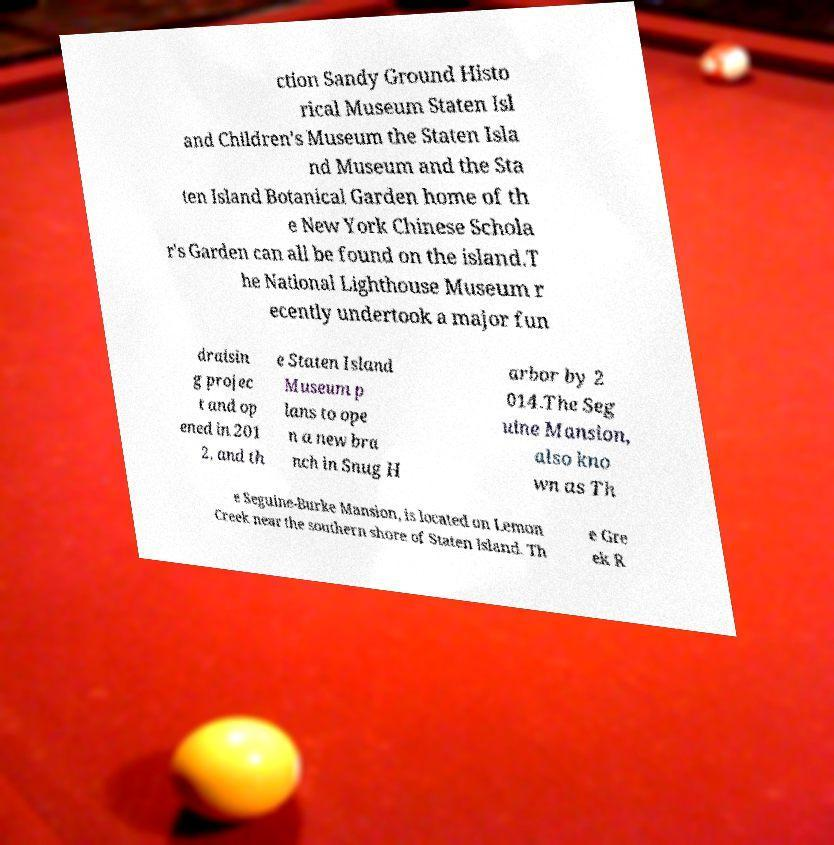What messages or text are displayed in this image? I need them in a readable, typed format. ction Sandy Ground Histo rical Museum Staten Isl and Children's Museum the Staten Isla nd Museum and the Sta ten Island Botanical Garden home of th e New York Chinese Schola r's Garden can all be found on the island.T he National Lighthouse Museum r ecently undertook a major fun draisin g projec t and op ened in 201 2, and th e Staten Island Museum p lans to ope n a new bra nch in Snug H arbor by 2 014.The Seg uine Mansion, also kno wn as Th e Seguine-Burke Mansion, is located on Lemon Creek near the southern shore of Staten Island. Th e Gre ek R 